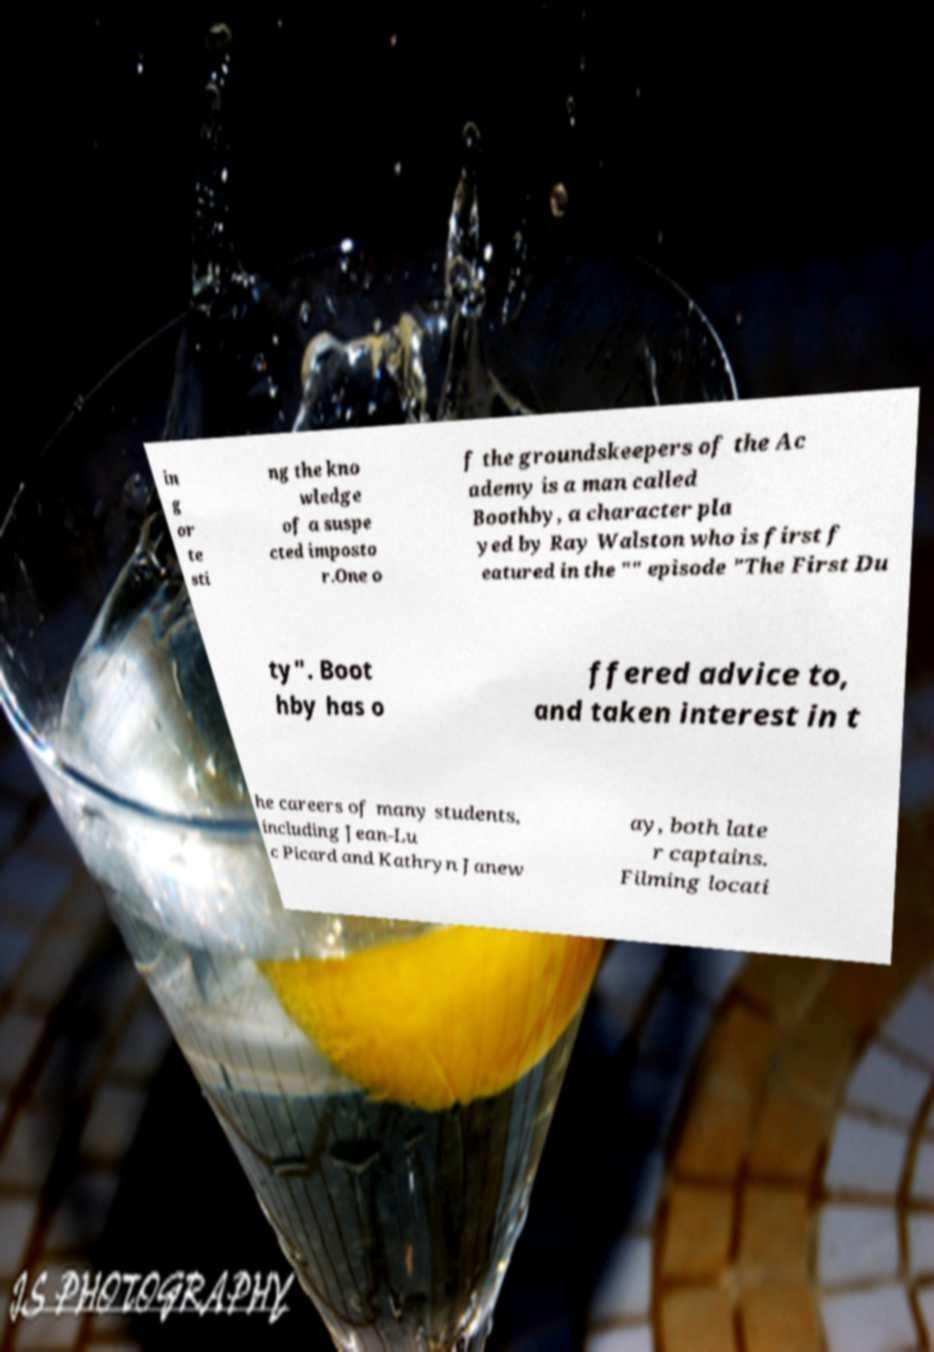There's text embedded in this image that I need extracted. Can you transcribe it verbatim? in g or te sti ng the kno wledge of a suspe cted imposto r.One o f the groundskeepers of the Ac ademy is a man called Boothby, a character pla yed by Ray Walston who is first f eatured in the "" episode "The First Du ty". Boot hby has o ffered advice to, and taken interest in t he careers of many students, including Jean-Lu c Picard and Kathryn Janew ay, both late r captains. Filming locati 